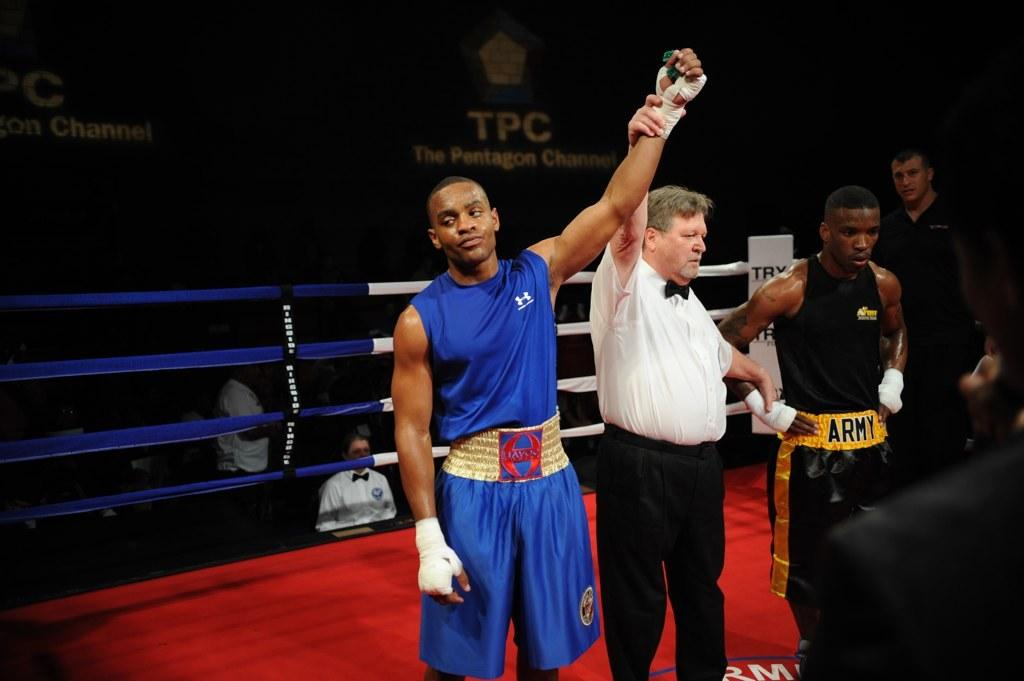<image>
Relay a brief, clear account of the picture shown. The initials TPC stands for the Pentagon Channel. 